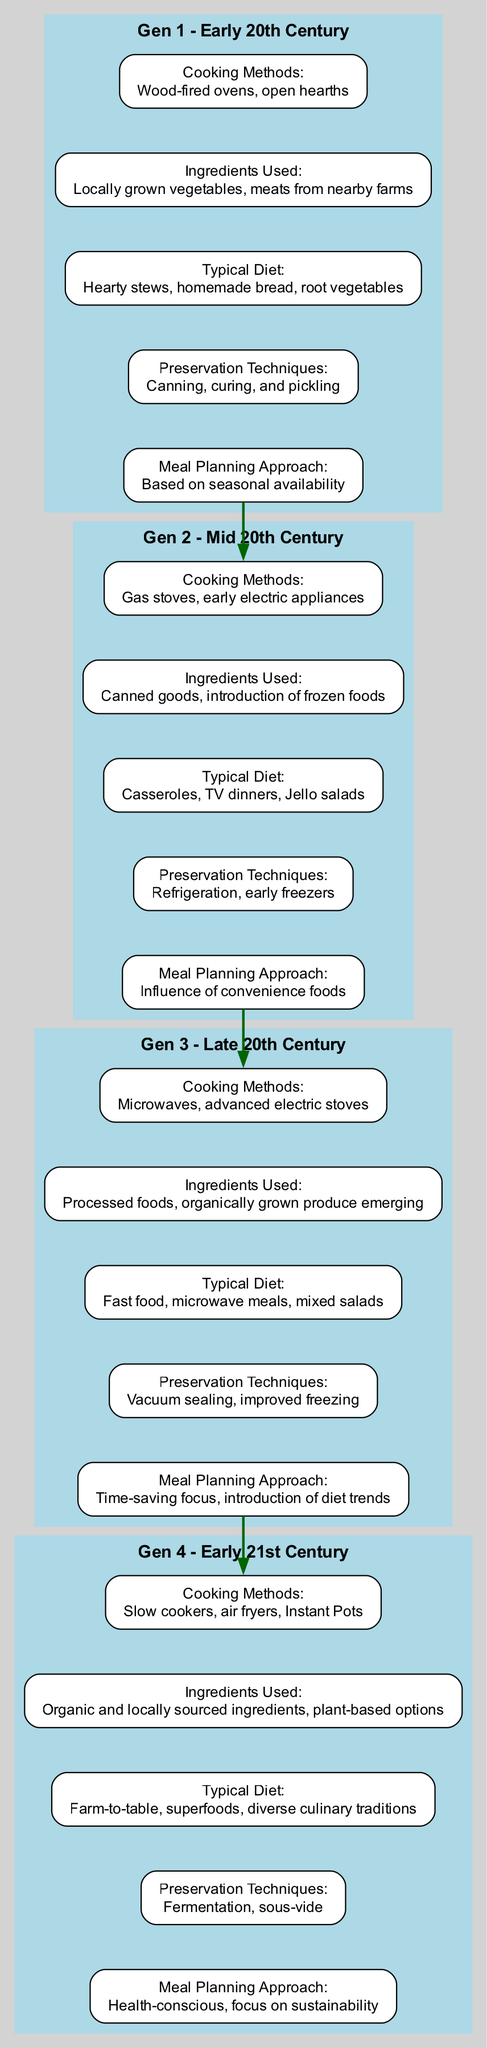What are the cooking methods in Gen 1? In Generation 1, the cooking methods listed are wood-fired ovens and open hearths.
Answer: Wood-fired ovens, open hearths What is the typical diet in Gen 3? The typical diet in Generation 3 includes fast food, microwave meals, and mixed salads.
Answer: Fast food, microwave meals, mixed salads How many elements are there in Gen 2? In Generation 2, there are five elements listed: cooking methods, ingredients used, typical diet, preservation techniques, and meal planning approach, which totals to five.
Answer: 5 What preservation technique appeared in Gen 4? In Generation 4, the preservation techniques mentioned include fermentation and sous-vide. Any one technique, for example fermentation, would be valid.
Answer: Fermentation Which generation introduced air fryers? Air fryers were introduced in Generation 4, indicated in the cooking methods section.
Answer: Gen 4 What is the relationship between the first and second generation in terms of meal planning? The meal planning approach in the first generation is based on seasonal availability, while the second generation's approach is influenced by convenience foods, showcasing a shift in focus.
Answer: Shift from seasonal to convenience How many generations focus on local ingredients? Both Generation 1 and Generation 4 focus on locally sourced ingredients, implying that there are two generations with this emphasis.
Answer: 2 What types of ingredients are predominantly used in Gen 2? The ingredients used in Generation 2 predominantly include canned goods and an introduction to frozen foods, both of which represent convenience.
Answer: Canned goods, frozen foods Which cooking methods are predominant in Gen 3? In Generation 3, the cooking methods predominantly used are microwaves and advanced electric stoves.
Answer: Microwaves, advanced electric stoves 